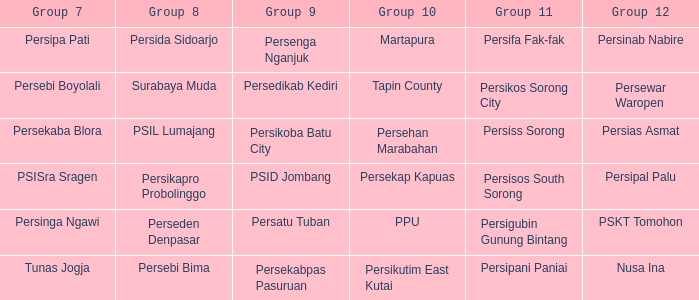Nusa Ina only played once while group 7 played. 1.0. 